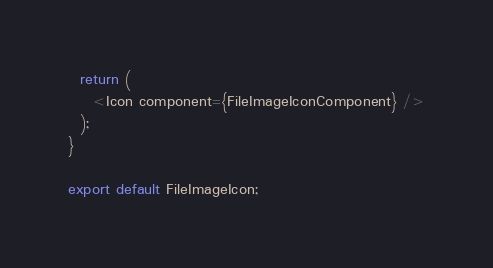<code> <loc_0><loc_0><loc_500><loc_500><_JavaScript_>  return (
    <Icon component={FileImageIconComponent} />
  );
}

export default FileImageIcon;
</code> 